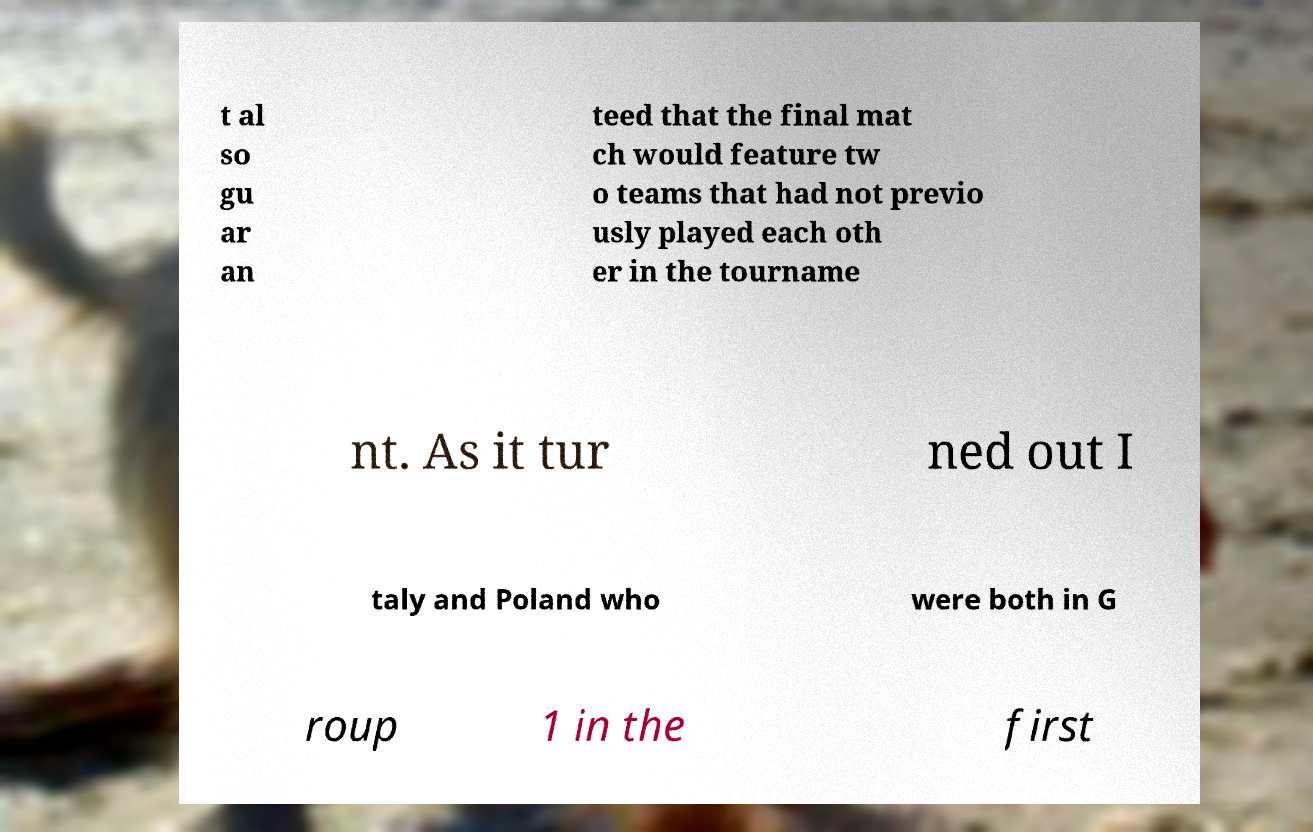Could you extract and type out the text from this image? t al so gu ar an teed that the final mat ch would feature tw o teams that had not previo usly played each oth er in the tourname nt. As it tur ned out I taly and Poland who were both in G roup 1 in the first 